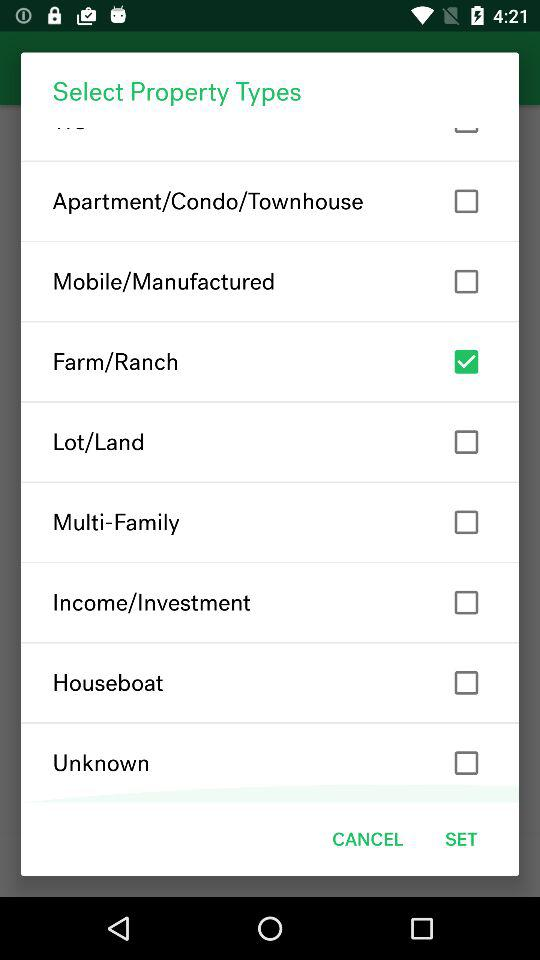How many property types are there?
Answer the question using a single word or phrase. 9 